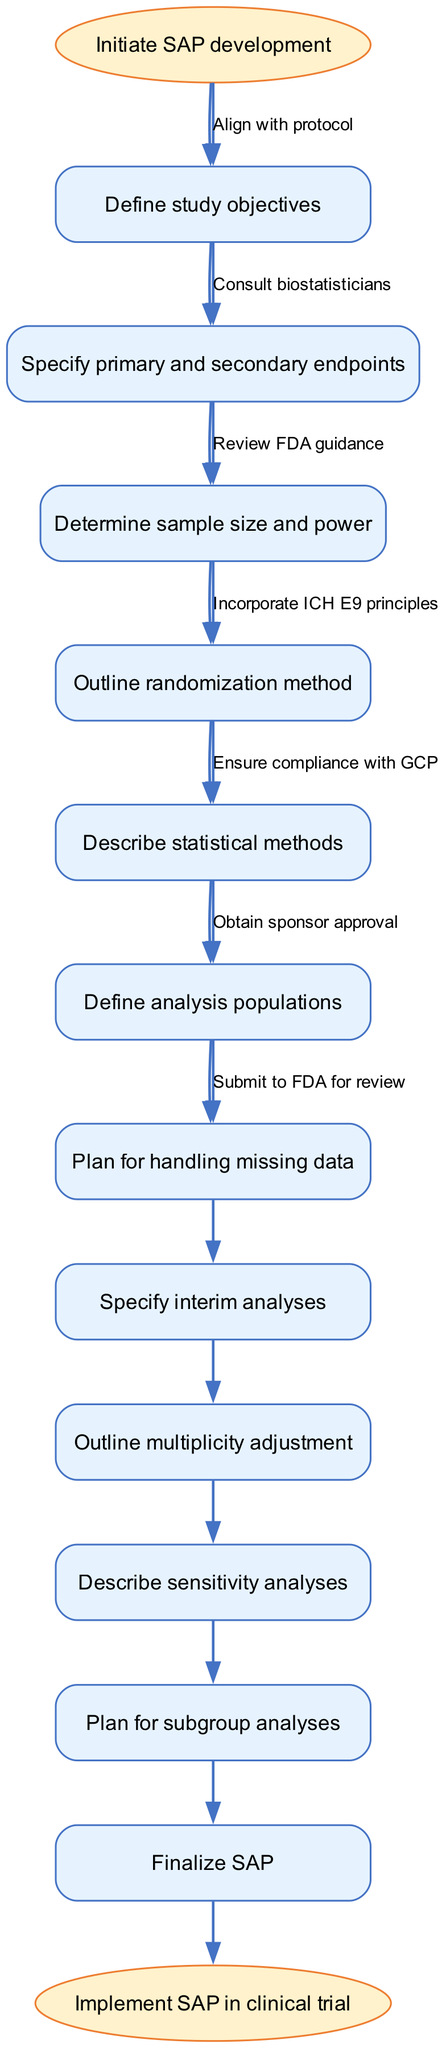What is the first step in the SAP development workflow? The first step in the workflow is indicated by the starting node, which states "Initiate SAP development."
Answer: Initiate SAP development How many nodes are there in the diagram? Each unique step in the workflow represents a node. Counting the starting and ending nodes plus the main nodes, we have 13 nodes in total.
Answer: 13 What is the final step before implementing the SAP? The last main step outlined in the diagram is "Finalize SAP," which precedes the implementation stage.
Answer: Finalize SAP What connects "Describe statistical methods" to "Define analysis populations"? "Consult biostatisticians" is noted as the edge that connects these two nodes, indicating this is a necessary consultation step.
Answer: Consult biostatisticians How many edges flow from the start node? There is one edge that leads from the start node to the first main step, which indicates the direction of flow in the workflow.
Answer: 1 Which step follows after "Specify primary and secondary endpoints"? The next node in the sequence directly following that step is "Determine sample size and power," which provides a logical progression in the planning process.
Answer: Determine sample size and power What is the last node in the workflow before the end? The last main node before reaching the endpoint of the workflow is "Finalize SAP." This connects the planning process to the eventual implementation.
Answer: Finalize SAP Which edge signifies compliance with regulatory standards? The edge labeled "Ensure compliance with GCP" reflects the necessary adherence to Good Clinical Practice, underscoring regulatory considerations in the workflow.
Answer: Ensure compliance with GCP What is the main reason to outline multiplicity adjustment? Outlining multiplicity adjustment is crucial to address the potential for inflated Type I error rates in statistical testing, ensuring valid results in analyses.
Answer: Address Type I error rates 